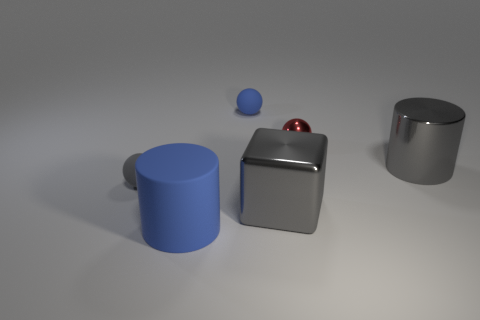There is a gray sphere; is it the same size as the blue rubber thing that is behind the tiny gray object?
Make the answer very short. Yes. What number of cylinders are either rubber things or small things?
Offer a terse response. 1. There is a gray thing that is made of the same material as the blue cylinder; what size is it?
Give a very brief answer. Small. Do the gray metallic thing to the right of the metal cube and the rubber thing that is to the right of the blue rubber cylinder have the same size?
Provide a short and direct response. No. How many objects are blue cylinders or purple matte things?
Provide a short and direct response. 1. What is the shape of the big blue rubber object?
Your answer should be very brief. Cylinder. The red object that is the same shape as the small blue thing is what size?
Give a very brief answer. Small. Is there any other thing that has the same material as the big gray cube?
Your response must be concise. Yes. There is a metal thing behind the gray thing that is to the right of the red metallic thing; what is its size?
Offer a terse response. Small. Are there the same number of small gray matte objects that are on the right side of the large blue rubber cylinder and gray blocks?
Your response must be concise. No. 